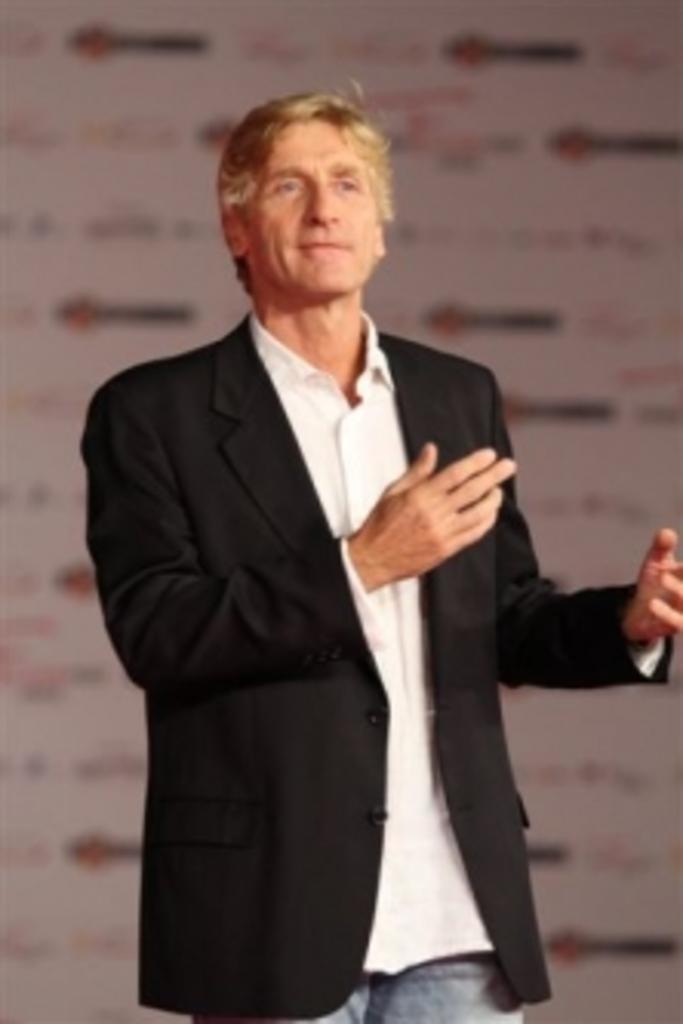Please provide a concise description of this image. In this image there is a person wearing a black suit is standing. Behind him there is a banner. 